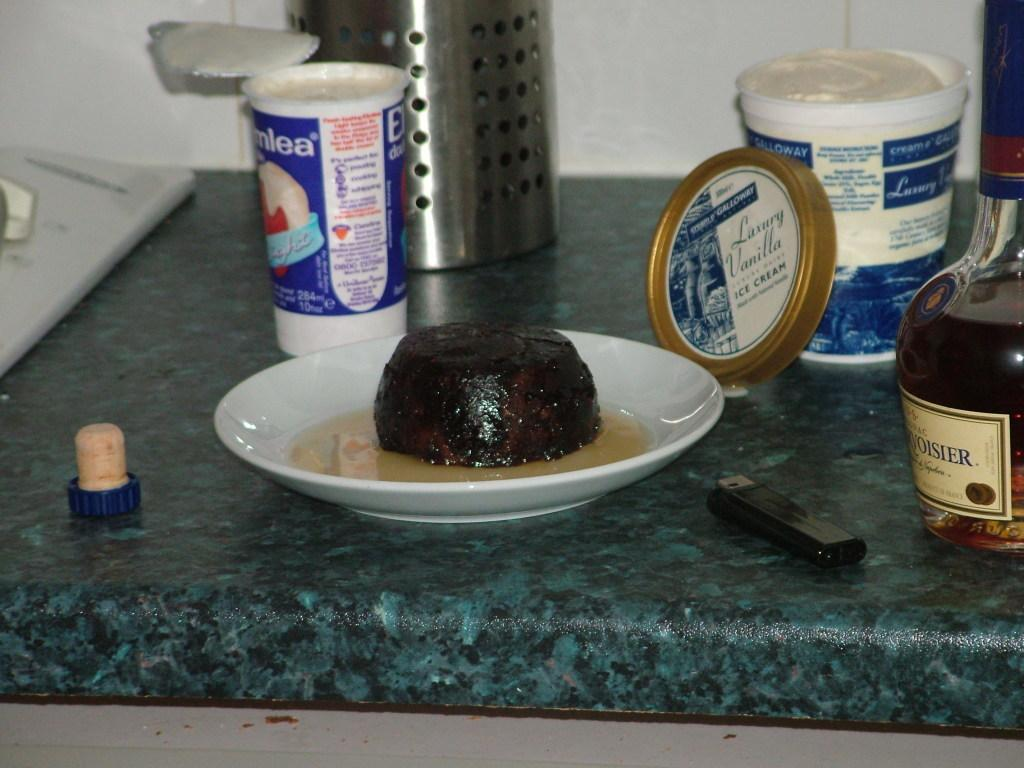<image>
Offer a succinct explanation of the picture presented. On a counter, amongst other food products, is an open container of luxury vanilla ice cream. 